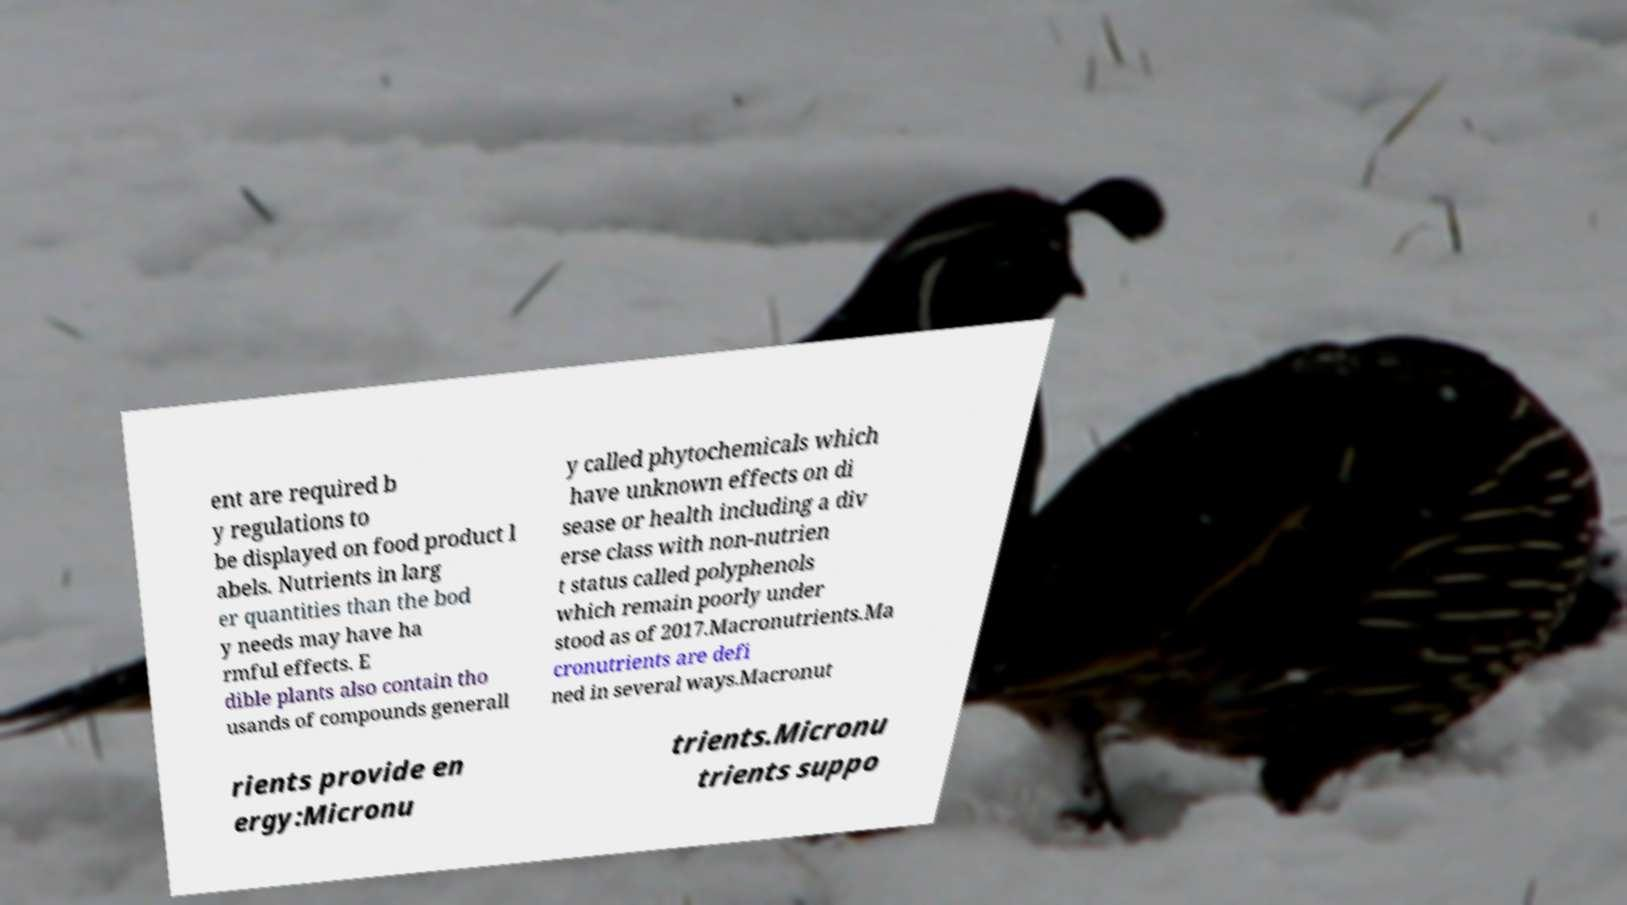Can you accurately transcribe the text from the provided image for me? ent are required b y regulations to be displayed on food product l abels. Nutrients in larg er quantities than the bod y needs may have ha rmful effects. E dible plants also contain tho usands of compounds generall y called phytochemicals which have unknown effects on di sease or health including a div erse class with non-nutrien t status called polyphenols which remain poorly under stood as of 2017.Macronutrients.Ma cronutrients are defi ned in several ways.Macronut rients provide en ergy:Micronu trients.Micronu trients suppo 